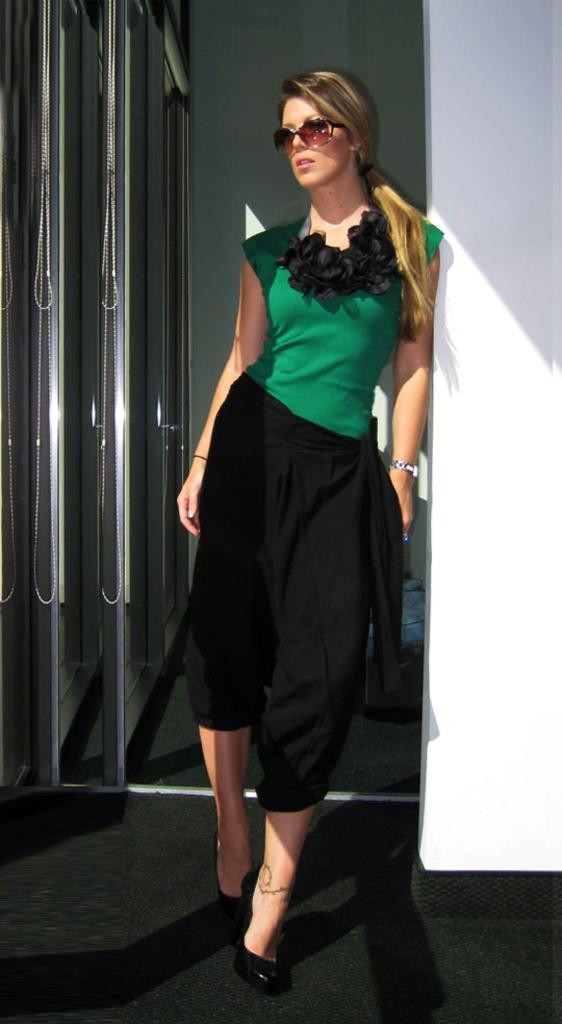How would you summarize this image in a sentence or two? In this image there is a woman standing, she is wearing goggles, there is a wall towards the right of the image, there is a wall behind the woman, there is door towards the left of the image, there is an object on the floor. 